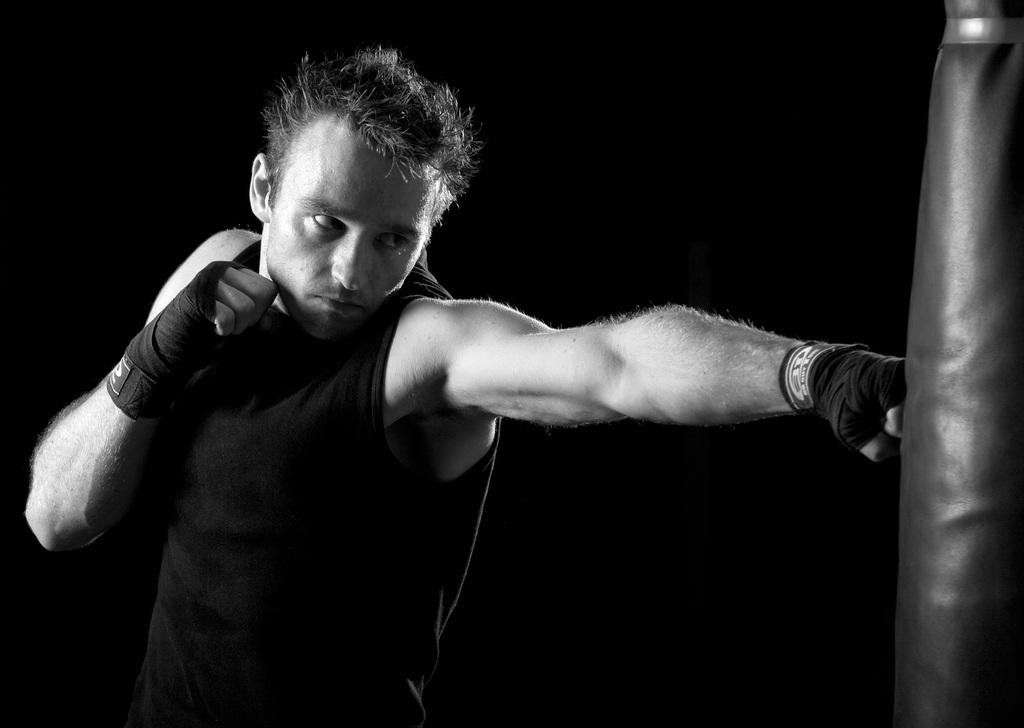Who is the person in the image? There is a man in the image. What is the man wearing? The man is wearing a black dress. What is the man doing in the image? The man is hitting a punching bag. What can be observed about the background of the image? The background of the image is dark. Can you see the sun in the image? No, the sun is not visible in the image; the background is dark. What type of cap is the man wearing in the image? There is no cap visible in the image; the man is wearing a black dress. 